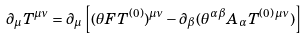Convert formula to latex. <formula><loc_0><loc_0><loc_500><loc_500>\partial _ { \mu } T ^ { \mu \nu } = \partial _ { \mu } \left [ ( \theta F T ^ { ( 0 ) } ) ^ { \mu \nu } - \partial _ { \beta } ( \theta ^ { \alpha \beta } A _ { \alpha } T ^ { ( 0 ) \, \mu \nu } ) \right ]</formula> 